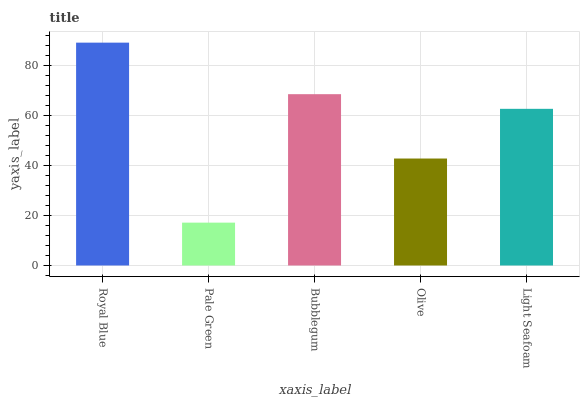Is Pale Green the minimum?
Answer yes or no. Yes. Is Royal Blue the maximum?
Answer yes or no. Yes. Is Bubblegum the minimum?
Answer yes or no. No. Is Bubblegum the maximum?
Answer yes or no. No. Is Bubblegum greater than Pale Green?
Answer yes or no. Yes. Is Pale Green less than Bubblegum?
Answer yes or no. Yes. Is Pale Green greater than Bubblegum?
Answer yes or no. No. Is Bubblegum less than Pale Green?
Answer yes or no. No. Is Light Seafoam the high median?
Answer yes or no. Yes. Is Light Seafoam the low median?
Answer yes or no. Yes. Is Olive the high median?
Answer yes or no. No. Is Pale Green the low median?
Answer yes or no. No. 